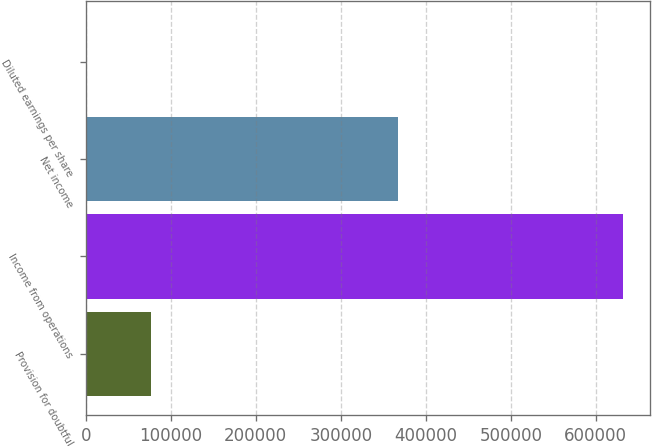<chart> <loc_0><loc_0><loc_500><loc_500><bar_chart><fcel>Provision for doubtful<fcel>Income from operations<fcel>Net income<fcel>Diluted earnings per share<nl><fcel>77280<fcel>632361<fcel>367432<fcel>0.27<nl></chart> 